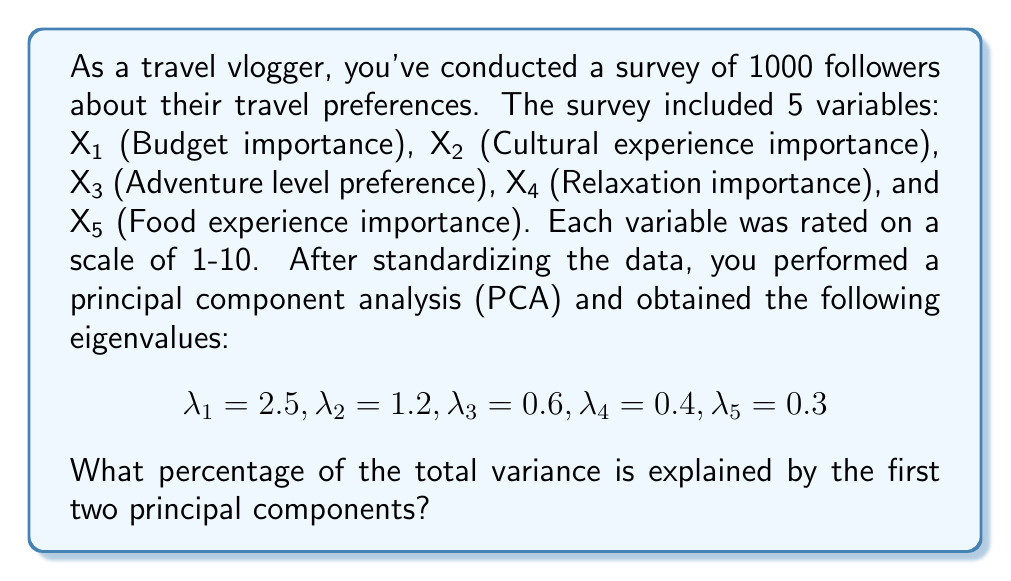Help me with this question. To solve this problem, we need to follow these steps:

1. Understand what eigenvalues represent in PCA:
   Eigenvalues represent the amount of variance explained by each principal component.

2. Calculate the total variance:
   The total variance is the sum of all eigenvalues.
   $$\text{Total Variance} = \sum_{i=1}^5 \lambda_i = 2.5 + 1.2 + 0.6 + 0.4 + 0.3 = 5$$

3. Calculate the variance explained by the first two principal components:
   $$\text{Variance explained by PC1 and PC2} = \lambda_1 + \lambda_2 = 2.5 + 1.2 = 3.7$$

4. Calculate the percentage of variance explained:
   $$\text{Percentage} = \frac{\text{Variance explained by PC1 and PC2}}{\text{Total Variance}} \times 100\%$$
   $$= \frac{3.7}{5} \times 100\% = 0.74 \times 100\% = 74\%$$

Therefore, the first two principal components explain 74% of the total variance in the travel preference data.
Answer: 74% 